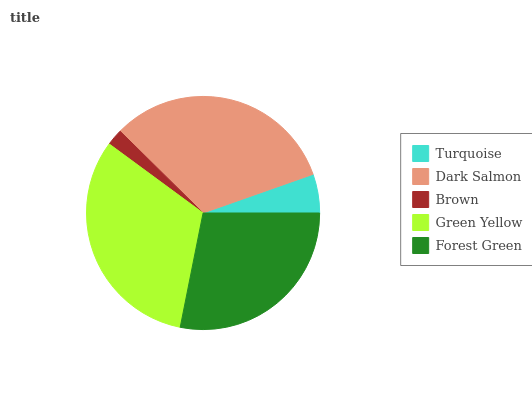Is Brown the minimum?
Answer yes or no. Yes. Is Dark Salmon the maximum?
Answer yes or no. Yes. Is Dark Salmon the minimum?
Answer yes or no. No. Is Brown the maximum?
Answer yes or no. No. Is Dark Salmon greater than Brown?
Answer yes or no. Yes. Is Brown less than Dark Salmon?
Answer yes or no. Yes. Is Brown greater than Dark Salmon?
Answer yes or no. No. Is Dark Salmon less than Brown?
Answer yes or no. No. Is Forest Green the high median?
Answer yes or no. Yes. Is Forest Green the low median?
Answer yes or no. Yes. Is Turquoise the high median?
Answer yes or no. No. Is Green Yellow the low median?
Answer yes or no. No. 